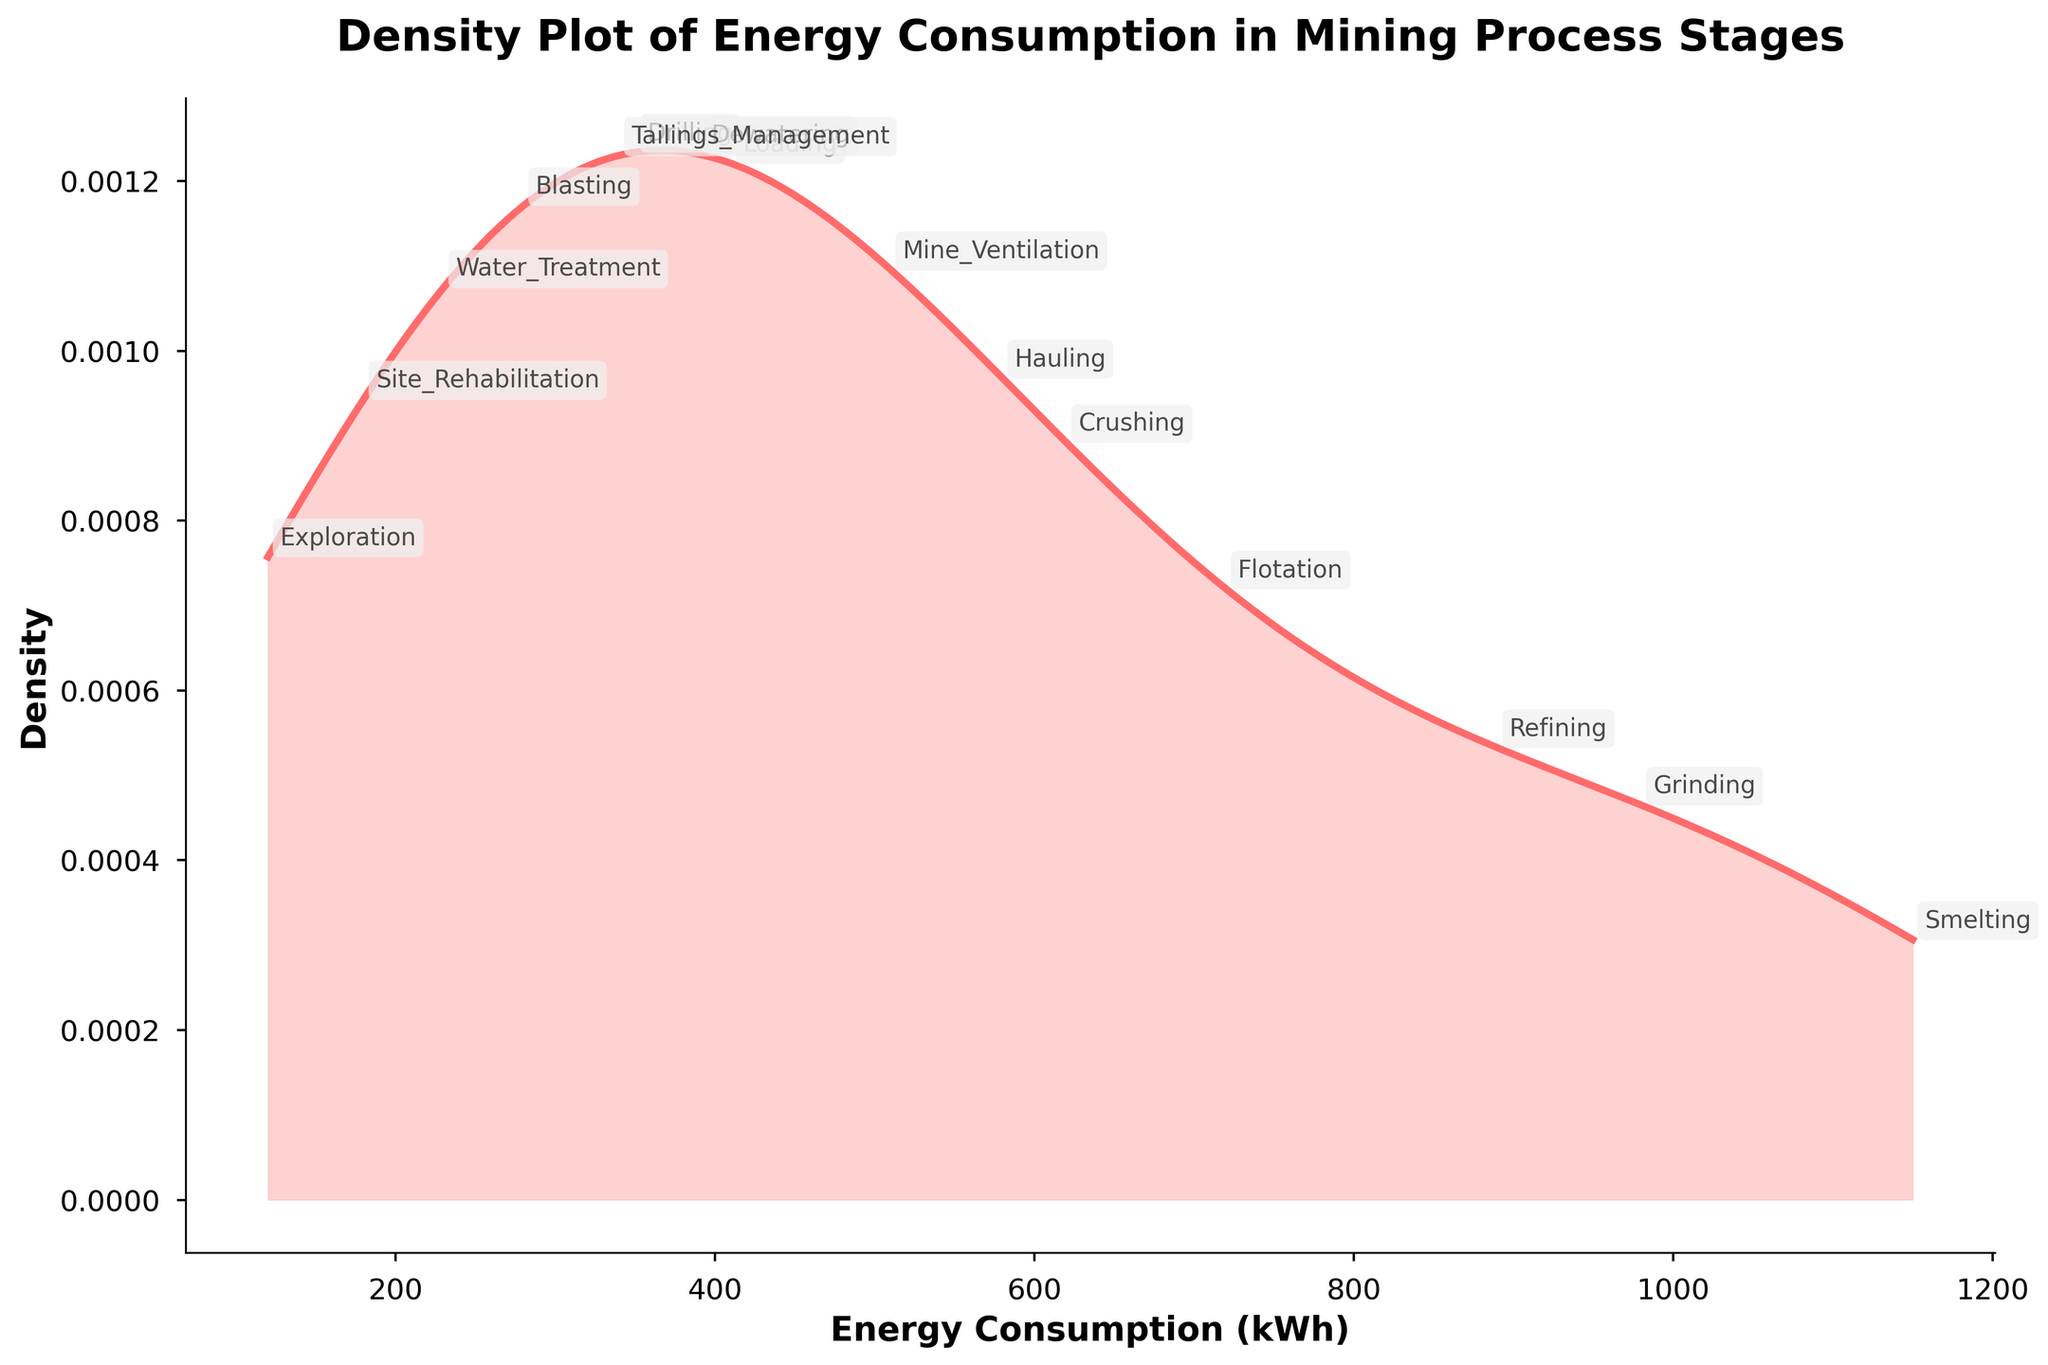what is the title of the plot? The title of the plot is located at the top center and is usually larger in font size compared to other text elements on the figure.
Answer: Density Plot of Energy Consumption in Mining Process Stages How many stages are labeled in the density plot? By counting the number of distinct labels annotated on the plot, you can determine the total number of stages.
Answer: 15 Which stage has the highest energy consumption? Locate the stage label that corresponds to the highest peak on the x-axis of energy consumption.
Answer: Smelting Which two stages have the closest energy consumption values on the x-axis? Identify the stages that are very near to each other, or almost overlapping, on the x-axis.
Answer: Drilling and Tailings Management What is the approximate energy consumption range for stages between the smallest and largest values? Calculate the difference between the smallest and largest points on the x-axis, which are approximately 120 kWh and 1150 kWh respectively.
Answer: 1030 kWh How does the energy consumption of Grinding compare to that of Refining? Compare the locations of Grinding and Refining on the x-axis to determine which has higher energy consumption.
Answer: Grinding is lower than Refining What is the shape of the density plot? The shape can be understood by inspecting the overall curve. Determine whether the plot follows a normal distribution, is skewed left or right, or has multiple peaks.
Answer: Right-skewed What does the area under the curve represent in the density plot? In a density plot, the area under the curve represents the probability distribution of the data values. Explain that the area under a PDF sums to 1.
Answer: Probability distribution of energy consumption Which stage has the lowest energy consumption, and what is its consumption value? Identify the stage located at the leftmost point of the x-axis and note its corresponding energy consumption.
Answer: Exploration, 120 kWh Do any stages have an energy consumption near 500 kWh? Which are they? Look at the region around 500 kWh on the x-axis and read the stage labels annotated close to this value.
Answer: Mine Ventilation 